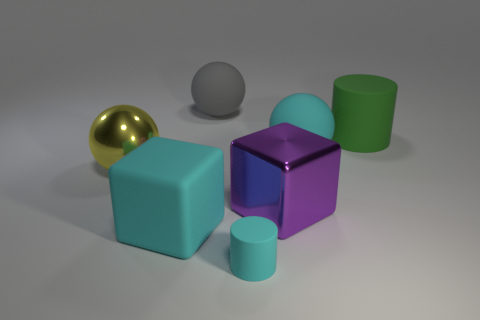Subtract all large matte balls. How many balls are left? 1 Subtract 1 balls. How many balls are left? 2 Subtract all brown spheres. Subtract all purple cylinders. How many spheres are left? 3 Add 1 big cubes. How many objects exist? 8 Subtract all spheres. How many objects are left? 4 Subtract all tiny green matte cylinders. Subtract all big purple metallic objects. How many objects are left? 6 Add 5 large yellow metallic balls. How many large yellow metallic balls are left? 6 Add 3 blue balls. How many blue balls exist? 3 Subtract 0 green blocks. How many objects are left? 7 